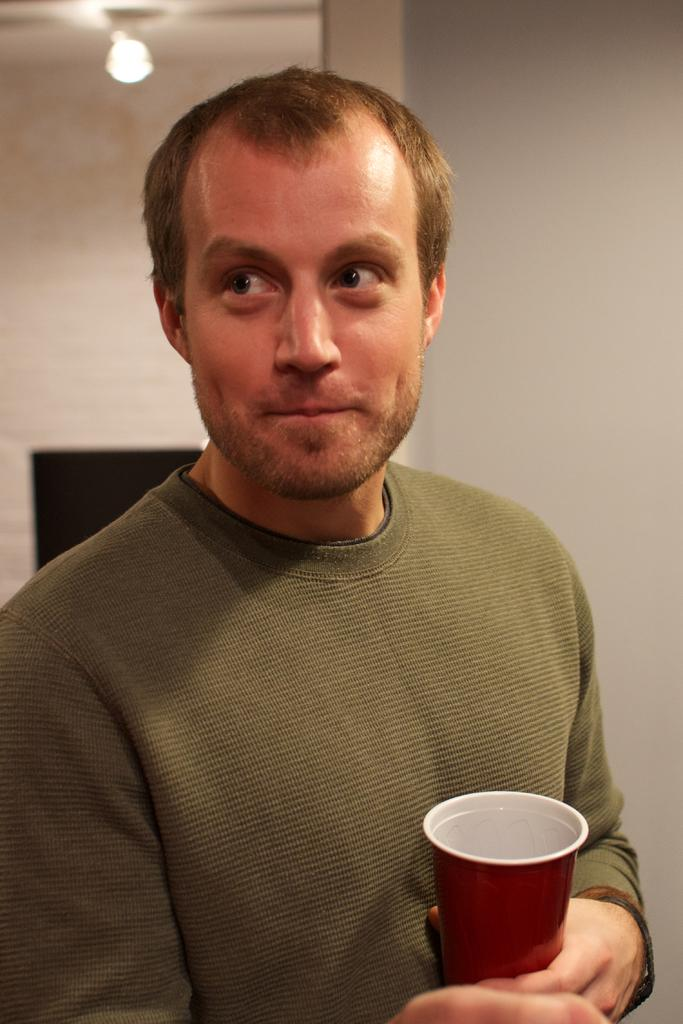What is the main subject of the image? There is a person in the image. What is the person holding in his hand? The person is holding a glass in his hand. Can you describe any other objects ornamental or functional objects in the image? There is a lamp on the ceiling in the image. How many cherries are on the snail in the image? There is no snail or cherries present in the image. 